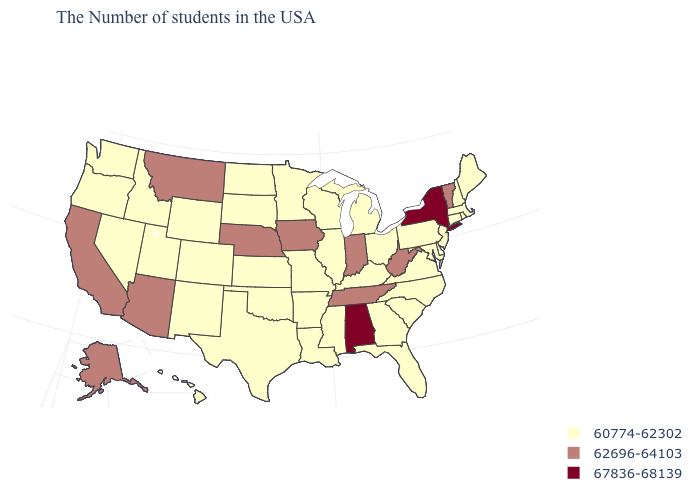Does the map have missing data?
Concise answer only. No. What is the value of Oregon?
Write a very short answer. 60774-62302. What is the value of Michigan?
Give a very brief answer. 60774-62302. Which states hav the highest value in the MidWest?
Short answer required. Indiana, Iowa, Nebraska. Name the states that have a value in the range 60774-62302?
Give a very brief answer. Maine, Massachusetts, Rhode Island, New Hampshire, Connecticut, New Jersey, Delaware, Maryland, Pennsylvania, Virginia, North Carolina, South Carolina, Ohio, Florida, Georgia, Michigan, Kentucky, Wisconsin, Illinois, Mississippi, Louisiana, Missouri, Arkansas, Minnesota, Kansas, Oklahoma, Texas, South Dakota, North Dakota, Wyoming, Colorado, New Mexico, Utah, Idaho, Nevada, Washington, Oregon, Hawaii. Does Alabama have the highest value in the USA?
Answer briefly. Yes. What is the value of Nevada?
Write a very short answer. 60774-62302. What is the value of North Carolina?
Answer briefly. 60774-62302. What is the lowest value in the USA?
Give a very brief answer. 60774-62302. Does New Mexico have the same value as Vermont?
Keep it brief. No. Does Delaware have a higher value than Iowa?
Concise answer only. No. Does Pennsylvania have a lower value than California?
Concise answer only. Yes. Among the states that border Texas , which have the lowest value?
Write a very short answer. Louisiana, Arkansas, Oklahoma, New Mexico. How many symbols are there in the legend?
Answer briefly. 3. Is the legend a continuous bar?
Answer briefly. No. 